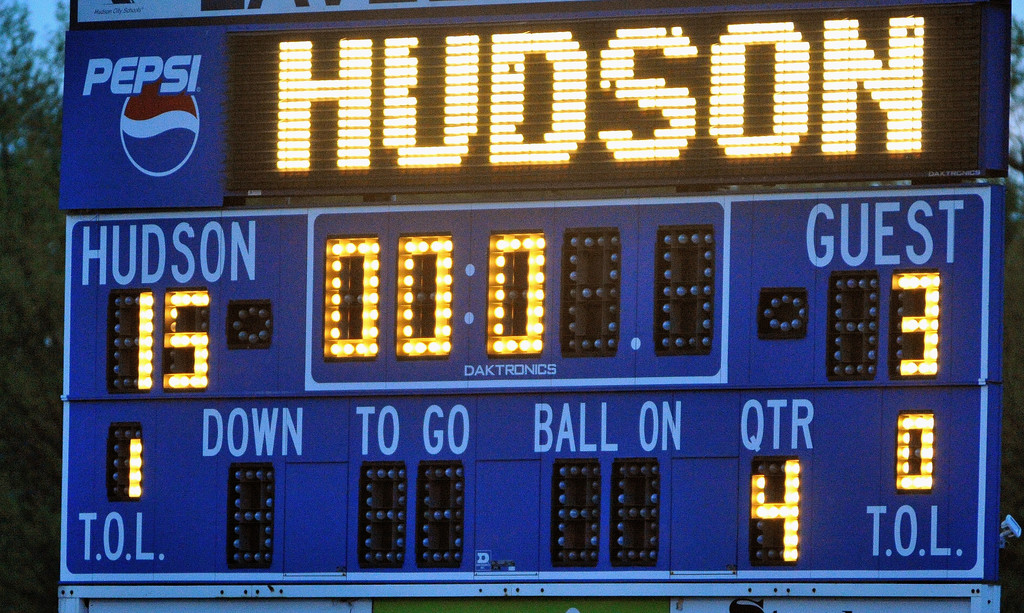Write a detailed description of the given image. The image features an illuminating scoreboard, sponsored by Pepsi, capturing a significant moment at the end of a football game. The scoreboard, manufactured by Daktronics, shows the guest team leading Hudson with a final score of 33-18. It indicates that this decisive moment came at the end of the fourth quarter. Additionally, information on the scoreboard provides an insight into the game's status with details such as the down number, yards to go, and available timeouts, emphasizing the guest's definitive victory. This detailed presentation not only reflects the outcome but also amplifies the excitement surrounding the event. 